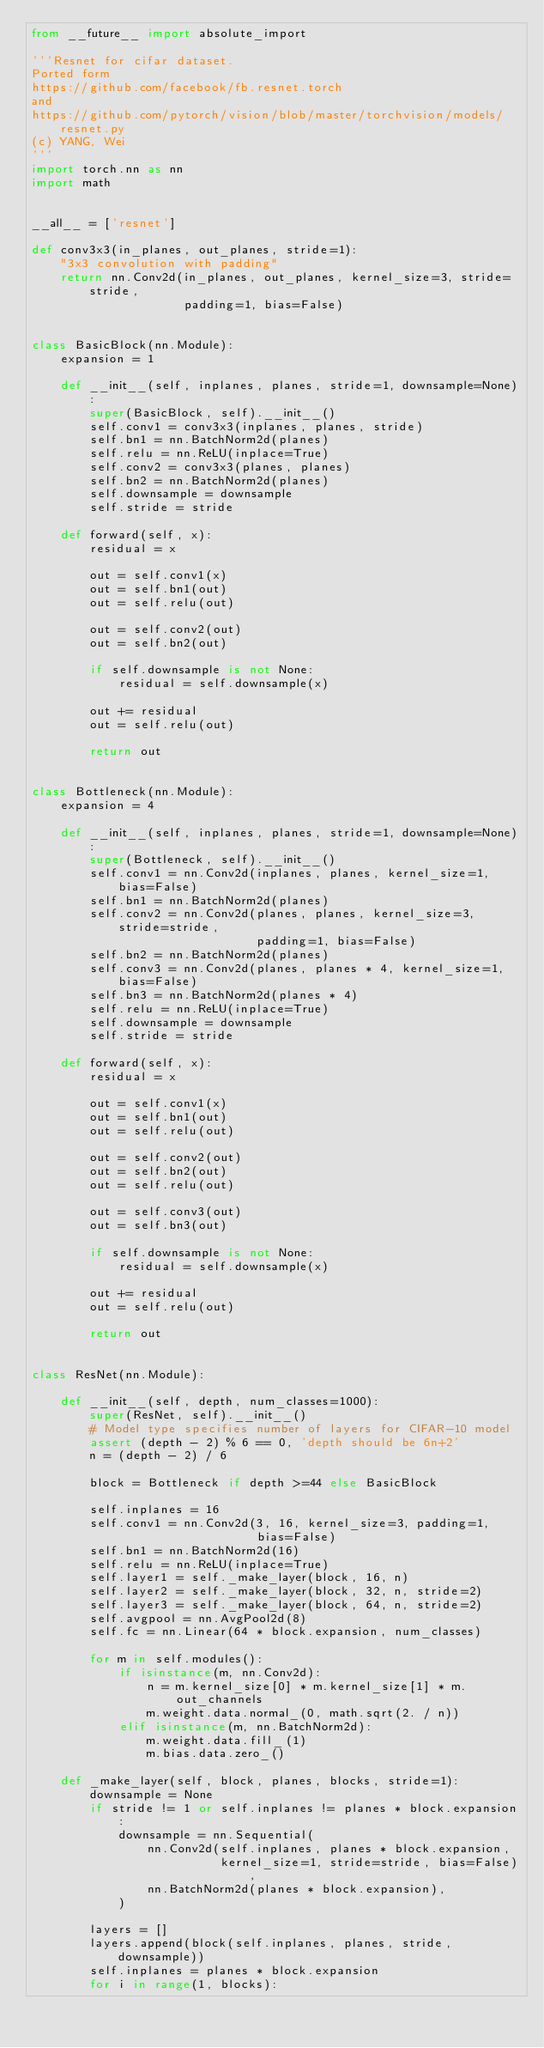<code> <loc_0><loc_0><loc_500><loc_500><_Python_>from __future__ import absolute_import

'''Resnet for cifar dataset. 
Ported form 
https://github.com/facebook/fb.resnet.torch
and
https://github.com/pytorch/vision/blob/master/torchvision/models/resnet.py
(c) YANG, Wei 
'''
import torch.nn as nn
import math


__all__ = ['resnet']

def conv3x3(in_planes, out_planes, stride=1):
    "3x3 convolution with padding"
    return nn.Conv2d(in_planes, out_planes, kernel_size=3, stride=stride,
                     padding=1, bias=False)


class BasicBlock(nn.Module):
    expansion = 1

    def __init__(self, inplanes, planes, stride=1, downsample=None):
        super(BasicBlock, self).__init__()
        self.conv1 = conv3x3(inplanes, planes, stride)
        self.bn1 = nn.BatchNorm2d(planes)
        self.relu = nn.ReLU(inplace=True)
        self.conv2 = conv3x3(planes, planes)
        self.bn2 = nn.BatchNorm2d(planes)
        self.downsample = downsample
        self.stride = stride

    def forward(self, x):
        residual = x

        out = self.conv1(x)
        out = self.bn1(out)
        out = self.relu(out)

        out = self.conv2(out)
        out = self.bn2(out)

        if self.downsample is not None:
            residual = self.downsample(x)

        out += residual
        out = self.relu(out)

        return out


class Bottleneck(nn.Module):
    expansion = 4

    def __init__(self, inplanes, planes, stride=1, downsample=None):
        super(Bottleneck, self).__init__()
        self.conv1 = nn.Conv2d(inplanes, planes, kernel_size=1, bias=False)
        self.bn1 = nn.BatchNorm2d(planes)
        self.conv2 = nn.Conv2d(planes, planes, kernel_size=3, stride=stride,
                               padding=1, bias=False)
        self.bn2 = nn.BatchNorm2d(planes)
        self.conv3 = nn.Conv2d(planes, planes * 4, kernel_size=1, bias=False)
        self.bn3 = nn.BatchNorm2d(planes * 4)
        self.relu = nn.ReLU(inplace=True)
        self.downsample = downsample
        self.stride = stride

    def forward(self, x):
        residual = x

        out = self.conv1(x)
        out = self.bn1(out)
        out = self.relu(out)

        out = self.conv2(out)
        out = self.bn2(out)
        out = self.relu(out)

        out = self.conv3(out)
        out = self.bn3(out)

        if self.downsample is not None:
            residual = self.downsample(x)

        out += residual
        out = self.relu(out)

        return out


class ResNet(nn.Module):

    def __init__(self, depth, num_classes=1000):
        super(ResNet, self).__init__()
        # Model type specifies number of layers for CIFAR-10 model
        assert (depth - 2) % 6 == 0, 'depth should be 6n+2'
        n = (depth - 2) / 6

        block = Bottleneck if depth >=44 else BasicBlock

        self.inplanes = 16
        self.conv1 = nn.Conv2d(3, 16, kernel_size=3, padding=1,
                               bias=False)
        self.bn1 = nn.BatchNorm2d(16)
        self.relu = nn.ReLU(inplace=True)
        self.layer1 = self._make_layer(block, 16, n)
        self.layer2 = self._make_layer(block, 32, n, stride=2)
        self.layer3 = self._make_layer(block, 64, n, stride=2)
        self.avgpool = nn.AvgPool2d(8)
        self.fc = nn.Linear(64 * block.expansion, num_classes)

        for m in self.modules():
            if isinstance(m, nn.Conv2d):
                n = m.kernel_size[0] * m.kernel_size[1] * m.out_channels
                m.weight.data.normal_(0, math.sqrt(2. / n))
            elif isinstance(m, nn.BatchNorm2d):
                m.weight.data.fill_(1)
                m.bias.data.zero_()

    def _make_layer(self, block, planes, blocks, stride=1):
        downsample = None
        if stride != 1 or self.inplanes != planes * block.expansion:
            downsample = nn.Sequential(
                nn.Conv2d(self.inplanes, planes * block.expansion,
                          kernel_size=1, stride=stride, bias=False),
                nn.BatchNorm2d(planes * block.expansion),
            )

        layers = []
        layers.append(block(self.inplanes, planes, stride, downsample))
        self.inplanes = planes * block.expansion
        for i in range(1, blocks):</code> 